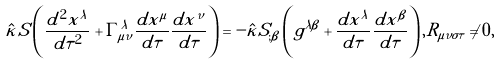Convert formula to latex. <formula><loc_0><loc_0><loc_500><loc_500>\hat { \kappa } S \left ( \frac { d ^ { 2 } x ^ { \lambda } } { d \tau ^ { 2 } } + \Gamma ^ { \lambda } _ { \mu \nu } \frac { d x ^ { \mu } } { d \tau } \frac { d x ^ { \nu } } { d \tau } \right ) = - \hat { \kappa } S _ { ; \beta } \left ( g ^ { \lambda \beta } + \frac { d x ^ { \lambda } } { d \tau } \frac { d x ^ { \beta } } { d \tau } \right ) , R _ { \mu \nu \sigma \tau } \neq 0 ,</formula> 